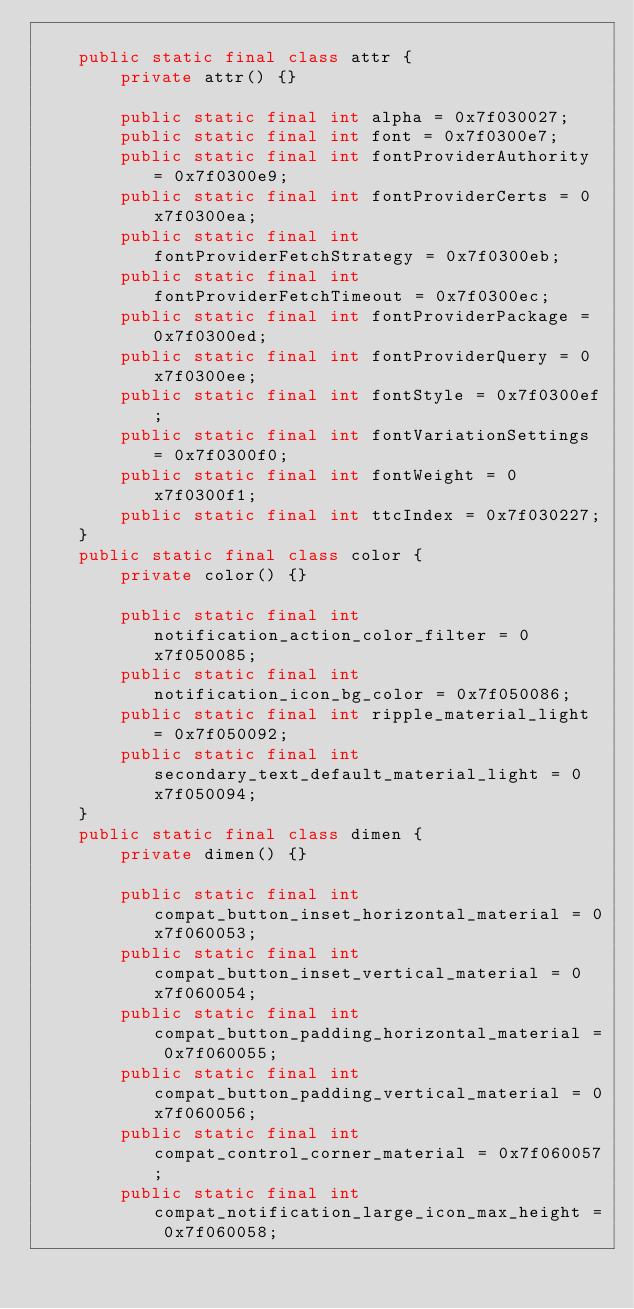<code> <loc_0><loc_0><loc_500><loc_500><_Java_>
    public static final class attr {
        private attr() {}

        public static final int alpha = 0x7f030027;
        public static final int font = 0x7f0300e7;
        public static final int fontProviderAuthority = 0x7f0300e9;
        public static final int fontProviderCerts = 0x7f0300ea;
        public static final int fontProviderFetchStrategy = 0x7f0300eb;
        public static final int fontProviderFetchTimeout = 0x7f0300ec;
        public static final int fontProviderPackage = 0x7f0300ed;
        public static final int fontProviderQuery = 0x7f0300ee;
        public static final int fontStyle = 0x7f0300ef;
        public static final int fontVariationSettings = 0x7f0300f0;
        public static final int fontWeight = 0x7f0300f1;
        public static final int ttcIndex = 0x7f030227;
    }
    public static final class color {
        private color() {}

        public static final int notification_action_color_filter = 0x7f050085;
        public static final int notification_icon_bg_color = 0x7f050086;
        public static final int ripple_material_light = 0x7f050092;
        public static final int secondary_text_default_material_light = 0x7f050094;
    }
    public static final class dimen {
        private dimen() {}

        public static final int compat_button_inset_horizontal_material = 0x7f060053;
        public static final int compat_button_inset_vertical_material = 0x7f060054;
        public static final int compat_button_padding_horizontal_material = 0x7f060055;
        public static final int compat_button_padding_vertical_material = 0x7f060056;
        public static final int compat_control_corner_material = 0x7f060057;
        public static final int compat_notification_large_icon_max_height = 0x7f060058;</code> 